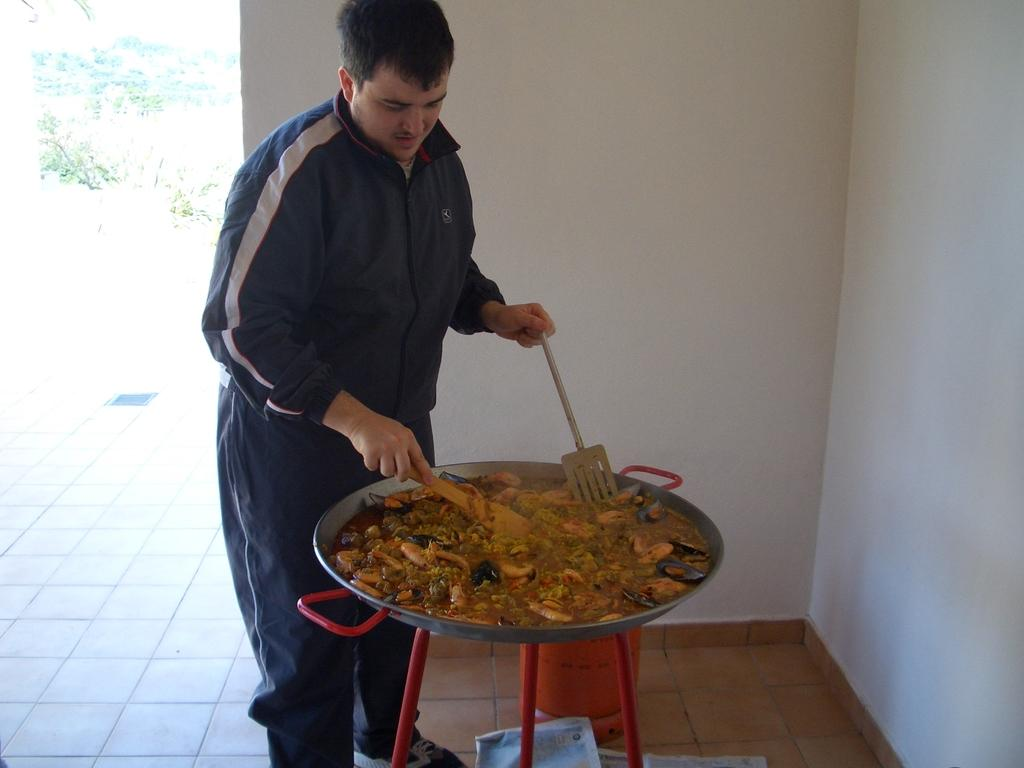What is the person in the image doing? The person is cooking food in a pan. What object can be seen in the image that is cylindrical in shape? There is a cylinder in the image. What is present on the floor in the image? There are objects on the floor in the image. What type of vegetation is visible in the image? There are plants in the image. What is the background of the image made up of? There is a wall in the image. What type of slope can be seen in the image? There is no slope present in the image. What is the dirt doing in the image? There is no dirt present in the image. 